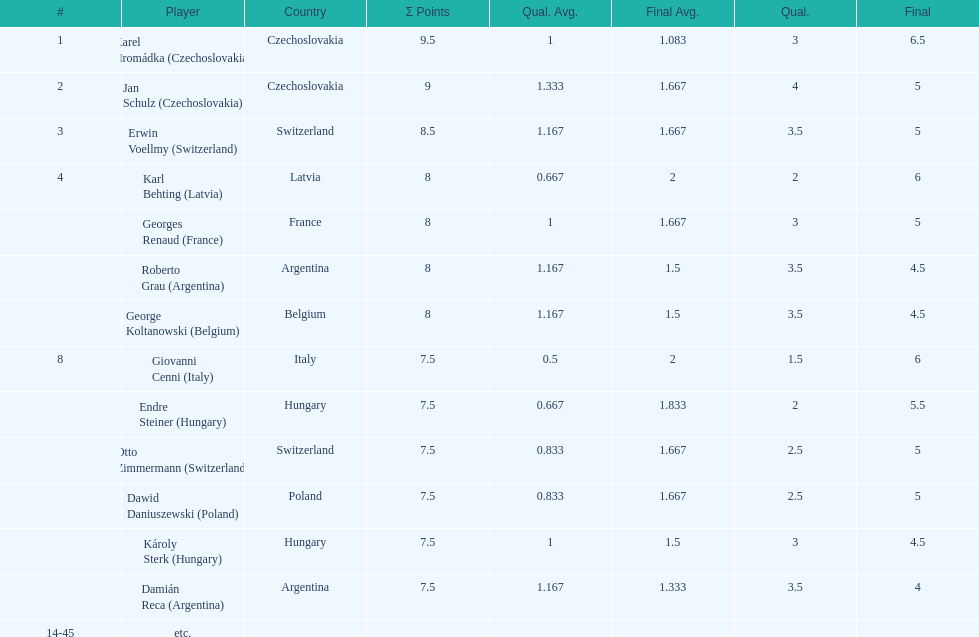The most points were scored by which player? Karel Hromádka. 